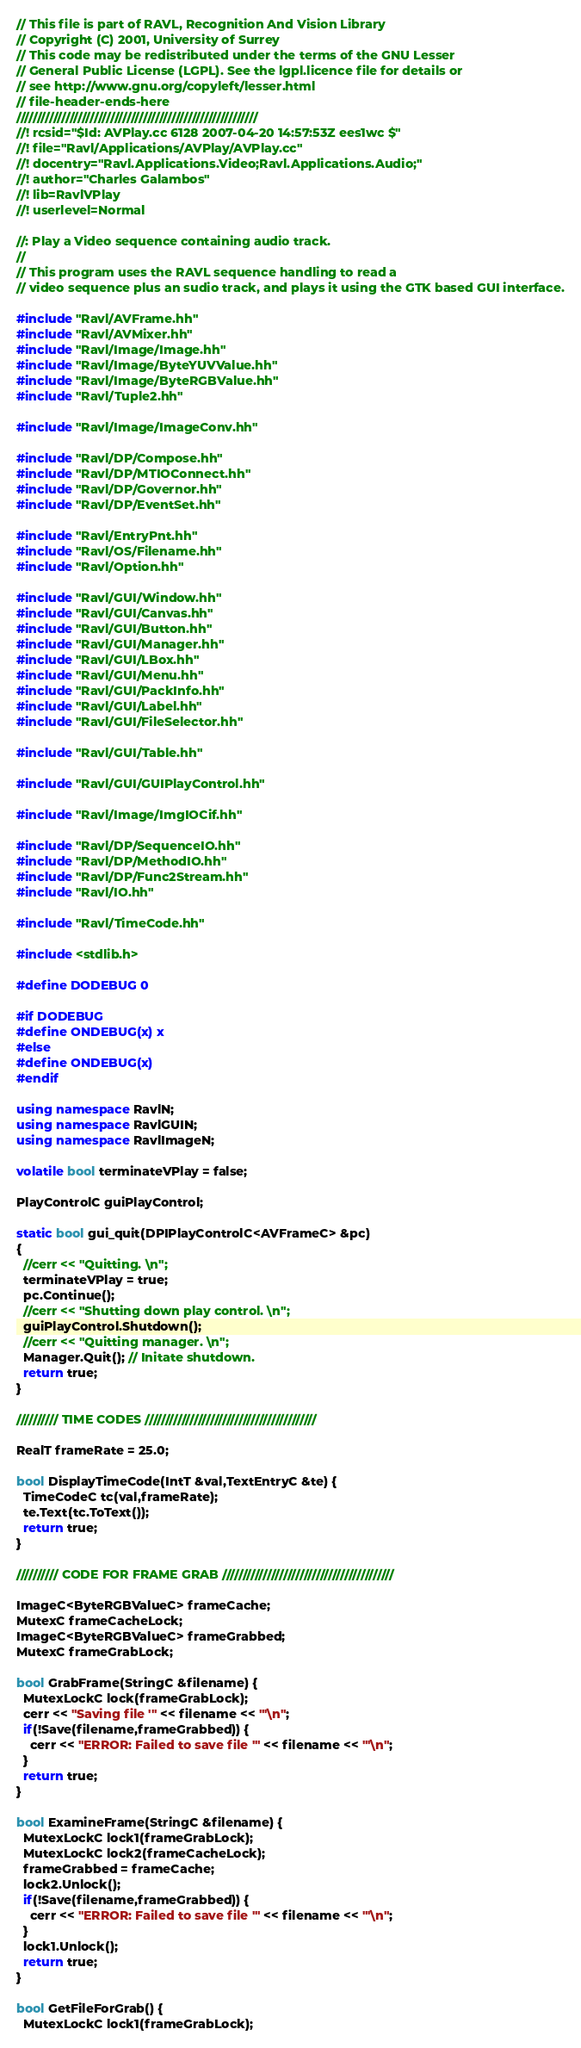<code> <loc_0><loc_0><loc_500><loc_500><_C++_>// This file is part of RAVL, Recognition And Vision Library 
// Copyright (C) 2001, University of Surrey
// This code may be redistributed under the terms of the GNU Lesser
// General Public License (LGPL). See the lgpl.licence file for details or
// see http://www.gnu.org/copyleft/lesser.html
// file-header-ends-here
///////////////////////////////////////////////////////////
//! rcsid="$Id: AVPlay.cc 6128 2007-04-20 14:57:53Z ees1wc $"
//! file="Ravl/Applications/AVPlay/AVPlay.cc"
//! docentry="Ravl.Applications.Video;Ravl.Applications.Audio;"
//! author="Charles Galambos"
//! lib=RavlVPlay
//! userlevel=Normal

//: Play a Video sequence containing audio track.
//
// This program uses the RAVL sequence handling to read a 
// video sequence plus an sudio track, and plays it using the GTK based GUI interface.

#include "Ravl/AVFrame.hh"
#include "Ravl/AVMixer.hh"
#include "Ravl/Image/Image.hh"
#include "Ravl/Image/ByteYUVValue.hh"
#include "Ravl/Image/ByteRGBValue.hh"
#include "Ravl/Tuple2.hh"

#include "Ravl/Image/ImageConv.hh"

#include "Ravl/DP/Compose.hh"
#include "Ravl/DP/MTIOConnect.hh"
#include "Ravl/DP/Governor.hh"
#include "Ravl/DP/EventSet.hh"

#include "Ravl/EntryPnt.hh"
#include "Ravl/OS/Filename.hh"
#include "Ravl/Option.hh"

#include "Ravl/GUI/Window.hh"
#include "Ravl/GUI/Canvas.hh"
#include "Ravl/GUI/Button.hh"
#include "Ravl/GUI/Manager.hh"
#include "Ravl/GUI/LBox.hh"
#include "Ravl/GUI/Menu.hh"
#include "Ravl/GUI/PackInfo.hh"
#include "Ravl/GUI/Label.hh"
#include "Ravl/GUI/FileSelector.hh"

#include "Ravl/GUI/Table.hh"

#include "Ravl/GUI/GUIPlayControl.hh"

#include "Ravl/Image/ImgIOCif.hh"

#include "Ravl/DP/SequenceIO.hh"
#include "Ravl/DP/MethodIO.hh"
#include "Ravl/DP/Func2Stream.hh"
#include "Ravl/IO.hh"

#include "Ravl/TimeCode.hh"

#include <stdlib.h>

#define DODEBUG 0

#if DODEBUG
#define ONDEBUG(x) x
#else
#define ONDEBUG(x)
#endif

using namespace RavlN;
using namespace RavlGUIN;
using namespace RavlImageN;

volatile bool terminateVPlay = false;

PlayControlC guiPlayControl;

static bool gui_quit(DPIPlayControlC<AVFrameC> &pc) 
{
  //cerr << "Quitting. \n";
  terminateVPlay = true;
  pc.Continue();
  //cerr << "Shutting down play control. \n";
  guiPlayControl.Shutdown();
  //cerr << "Quitting manager. \n";
  Manager.Quit(); // Initate shutdown.
  return true;
}

////////// TIME CODES //////////////////////////////////////////

RealT frameRate = 25.0;

bool DisplayTimeCode(IntT &val,TextEntryC &te) {
  TimeCodeC tc(val,frameRate);
  te.Text(tc.ToText());
  return true;
}

////////// CODE FOR FRAME GRAB //////////////////////////////////////////

ImageC<ByteRGBValueC> frameCache;
MutexC frameCacheLock;
ImageC<ByteRGBValueC> frameGrabbed;
MutexC frameGrabLock;

bool GrabFrame(StringC &filename) {
  MutexLockC lock(frameGrabLock);
  cerr << "Saving file '" << filename << "'\n";
  if(!Save(filename,frameGrabbed)) {
    cerr << "ERROR: Failed to save file '" << filename << "'\n";
  }
  return true;
}

bool ExamineFrame(StringC &filename) {
  MutexLockC lock1(frameGrabLock);
  MutexLockC lock2(frameCacheLock);
  frameGrabbed = frameCache;
  lock2.Unlock();
  if(!Save(filename,frameGrabbed)) {
    cerr << "ERROR: Failed to save file '" << filename << "'\n";
  }
  lock1.Unlock();
  return true;
}

bool GetFileForGrab() {
  MutexLockC lock1(frameGrabLock);</code> 